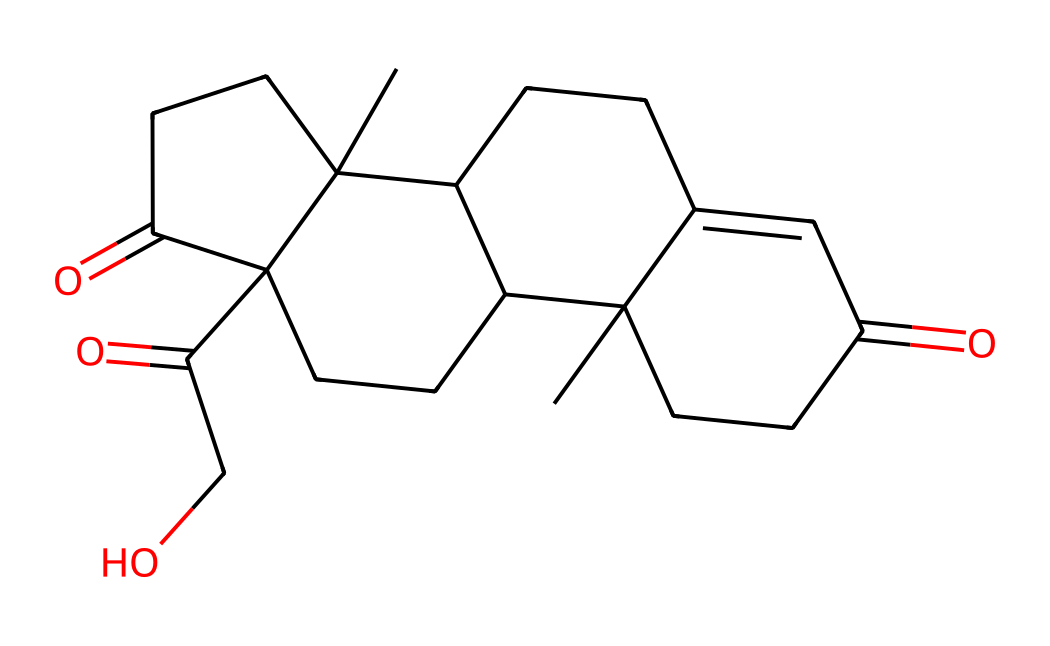How many carbon atoms are in this structure? By counting the number of carbon (C) atoms in the SMILES representation, we identify each 'C' and consider branches, resulting in a total of 21 carbon atoms.
Answer: 21 How many rings are present in this chemical structure? Analyzing the SMILES representation reveals multiple cycloalkane groups. We can visually count the rings formed by the connections in the structure, identifying 4 distinct rings.
Answer: 4 What is the functional group present in cortisol? In the chemical structure, we can see multiple carbonyl (C=O) groups indicated by the '=' sign, which denotes the presence of ketone functional groups.
Answer: ketone What type of hormone is cortisol classified as? The nature of cortisol, based on its structure and function in the body, indicates that it falls under the category of steroid hormones due to its four fused carbon rings configuration.
Answer: steroid Which part of the structure is crucial for cortisol's biological activity? The presence of the hydroxyl (-OH) group is critical for the interaction of cortisol with its receptors, which allows it to exert its biological effects in the body.
Answer: hydroxyl group What is the molecular weight of cortisol? Determining the molecular weight using the atomic masses from the chemical formula derived from the SMILES leads to calculating approximately 362.46 g/mol for cortisol.
Answer: 362.46 g/mol How many carbonyl groups are in the cortisol structure? Counting each carbonyl (C=O) indicated by '=' in the SMILES representation shows that there are 3 carbonyl groups present in the structure.
Answer: 3 